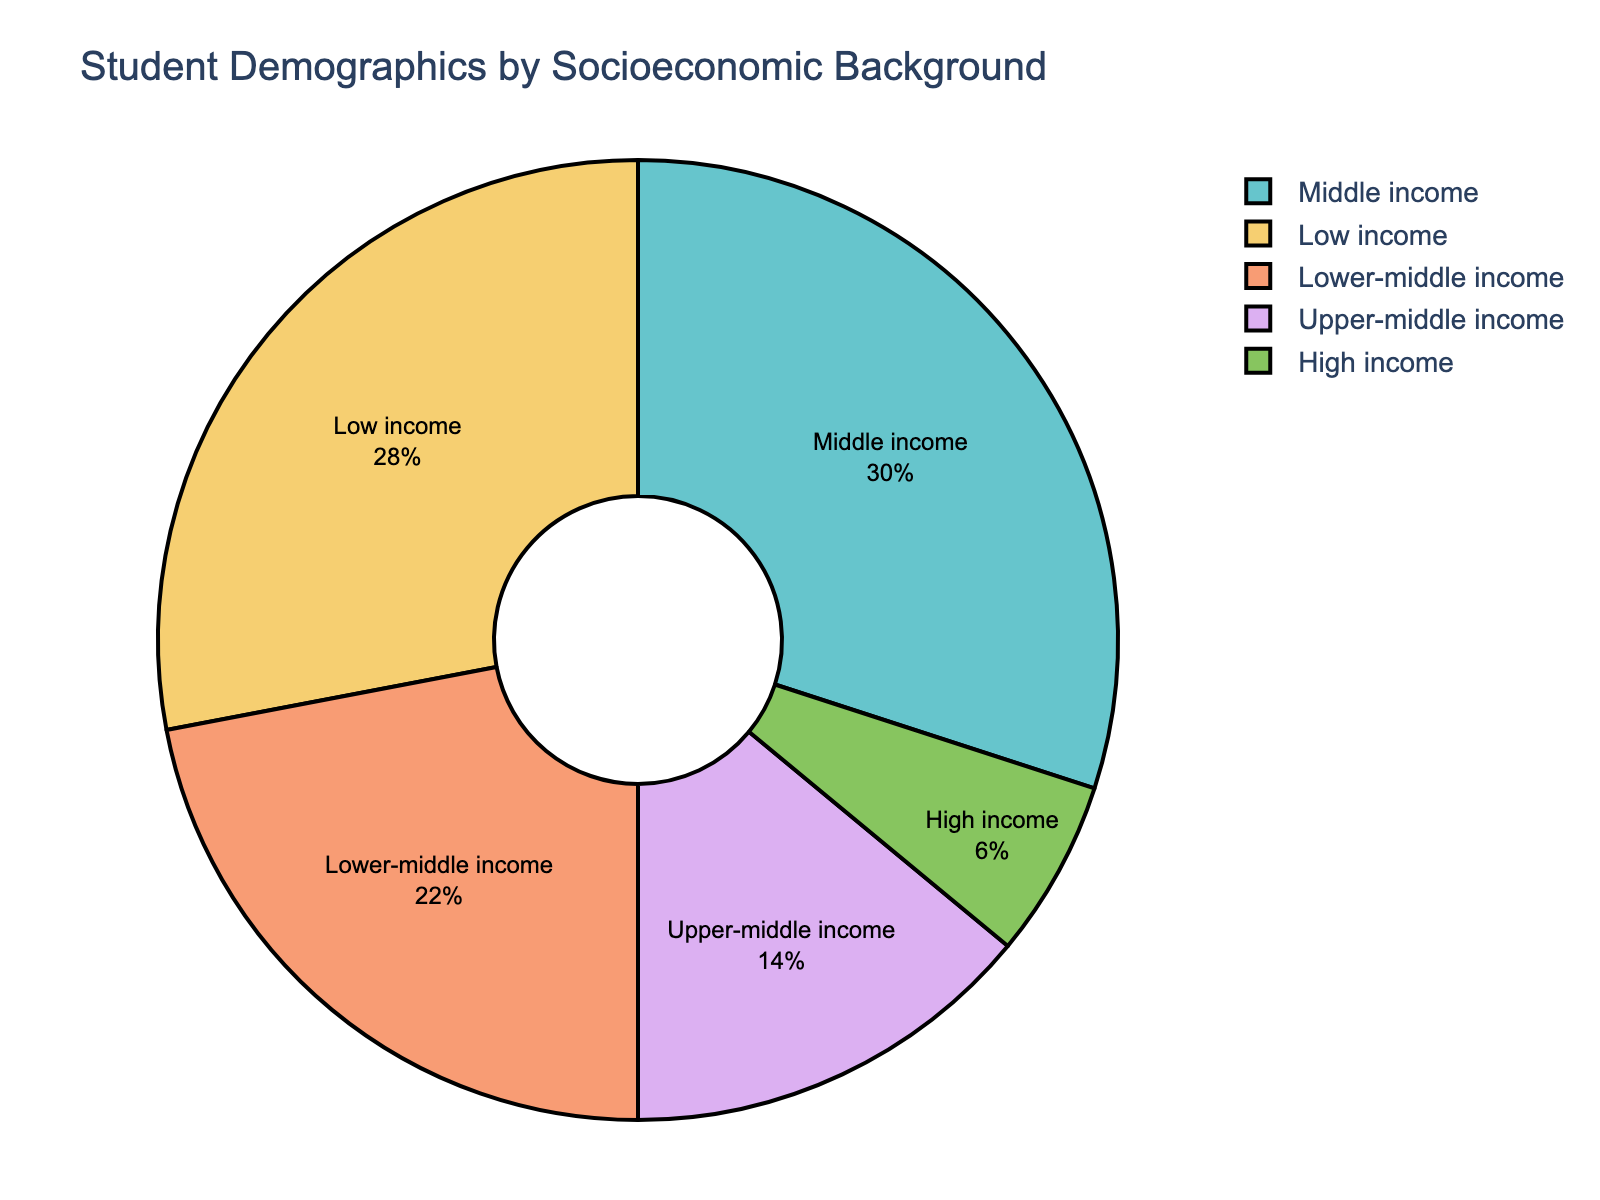What percentage of students come from either middle or upper-middle income backgrounds? To determine the percentage of students from either middle or upper-middle income backgrounds, we need to sum the individual percentages of these two categories: Middle income (30%) and Upper-middle income (14%). So, the sum is 30% + 14% = 44%.
Answer: 44% Which socioeconomic background has the highest percentage of students? From the pie chart, we observe the segments and their corresponding percentages. The segment with the highest percentage is Middle income, which accounts for 30% of the students.
Answer: Middle income What is the difference in percentage between students from low income and high income backgrounds? To find the difference in percentage between low-income and high-income student backgrounds, we subtract the high-income percentage (6%) from the low-income percentage (28%). So, 28% - 6% = 22%.
Answer: 22% Comparing lower-middle income and upper-middle income backgrounds, which group has a higher percentage and by how much? To compare these two categories, we look at their percentages: Lower-middle income students are 22%, while Upper-middle income students are 14%. The difference is 22% - 14% = 8%. Therefore, lower-middle income students have a higher percentage by 8%.
Answer: Lower-middle income by 8% What proportion of the total does the high-income group represent visually in the pie chart? In the pie chart, the high-income group represents a smaller segment compared to others, covering only 6% of the total. This small percentage is visually reflected by the smaller slice size in the pie chart.
Answer: 6% Is the combined percentage of low income and lower-middle income students larger than the percentage of middle income students? To determine this, we sum the percentages of low income (28%) and lower-middle income (22%) students. The total is 28% + 22% = 50%. We then compare this to the middle income percentage, which is 30%. Since 50% is larger than 30%, the combined percentage is indeed larger.
Answer: Yes Which socioeconomic background is represented with the second-largest slice in the pie chart? In the pie chart, the slices represent different socioeconomic backgrounds. The second-largest slice corresponds to the Low income group, which accounts for 28% of the students, just below the Middle income group's 30%.
Answer: Low income If we combine lower-middle income and upper-middle income backgrounds, what percentage of students do they represent? To find the combined percentage of students from lower-middle and upper-middle incomes, we add their individual percentages: Lower-middle income (22%) and Upper-middle income (14%). So, 22% + 14% = 36%.
Answer: 36% What is the total percentage of students from upper-middle and high-income backgrounds? To find the total percentage of students from upper-middle and high-income backgrounds, we add their respective percentages: Upper-middle income contributes 14% and high income contributes 6%. Therefore, the total is 14% + 6% = 20%.
Answer: 20% How much larger is the segment for low-income students compared to the segment for high-income students? To determine how much larger the low-income segment is compared to the high-income segment, we calculate the difference in their percentages: Low income (28%) and High income (6%). Thus, 28% - 6% = 22%.
Answer: 22% 